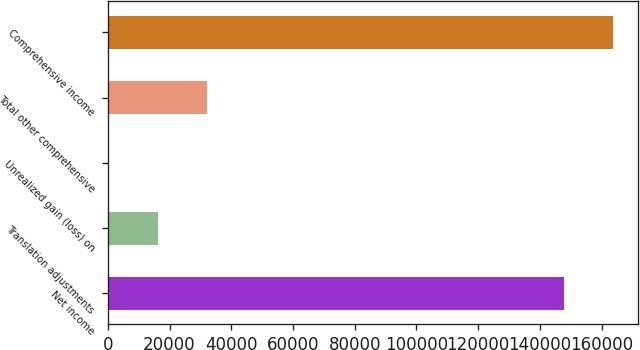Convert chart to OTSL. <chart><loc_0><loc_0><loc_500><loc_500><bar_chart><fcel>Net income<fcel>Translation adjustments<fcel>Unrealized gain (loss) on<fcel>Total other comprehensive<fcel>Comprehensive income<nl><fcel>147744<fcel>16137.9<fcel>241<fcel>32034.8<fcel>163641<nl></chart> 